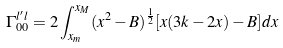Convert formula to latex. <formula><loc_0><loc_0><loc_500><loc_500>\Gamma ^ { l ^ { \prime } l } _ { 0 0 } = 2 \int ^ { x _ { M } } _ { x _ { m } } ( x ^ { 2 } - B ) ^ { \frac { 1 } { 2 } } [ x ( 3 k - 2 x ) - B ] d x</formula> 